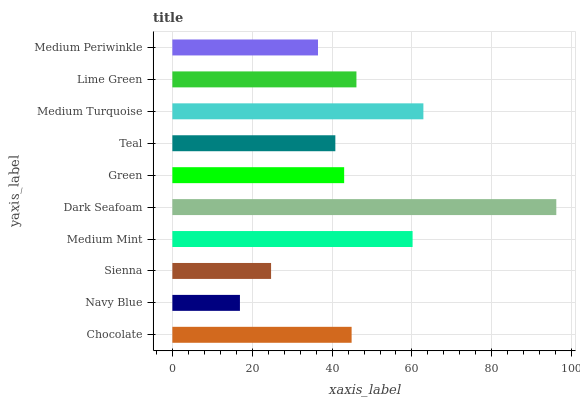Is Navy Blue the minimum?
Answer yes or no. Yes. Is Dark Seafoam the maximum?
Answer yes or no. Yes. Is Sienna the minimum?
Answer yes or no. No. Is Sienna the maximum?
Answer yes or no. No. Is Sienna greater than Navy Blue?
Answer yes or no. Yes. Is Navy Blue less than Sienna?
Answer yes or no. Yes. Is Navy Blue greater than Sienna?
Answer yes or no. No. Is Sienna less than Navy Blue?
Answer yes or no. No. Is Chocolate the high median?
Answer yes or no. Yes. Is Green the low median?
Answer yes or no. Yes. Is Sienna the high median?
Answer yes or no. No. Is Medium Mint the low median?
Answer yes or no. No. 